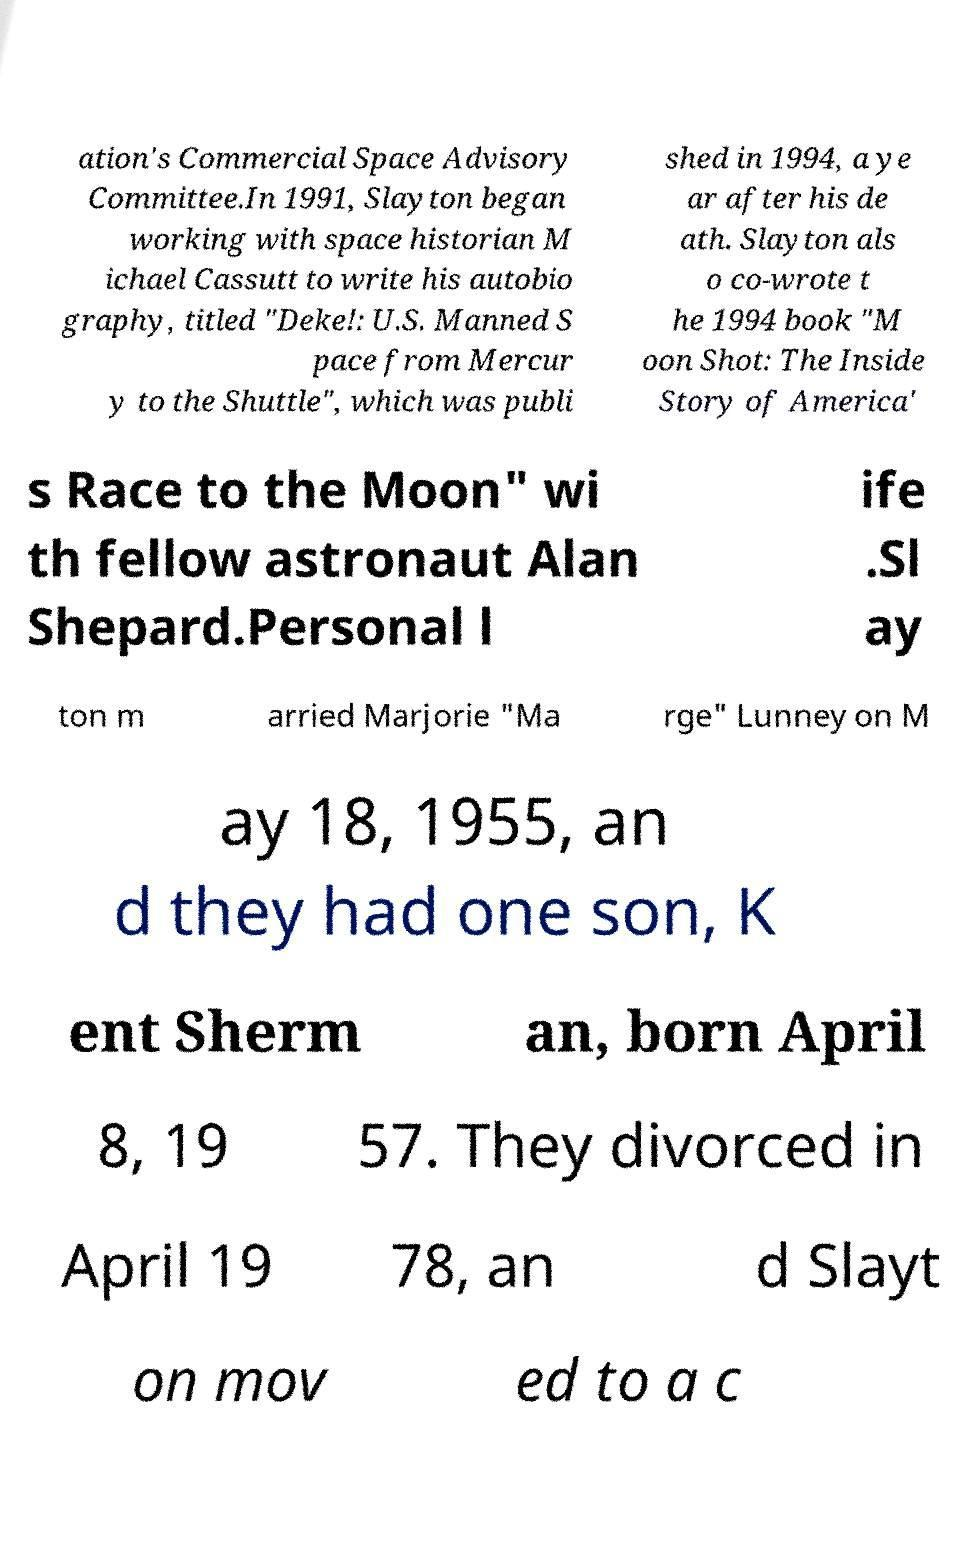There's text embedded in this image that I need extracted. Can you transcribe it verbatim? ation's Commercial Space Advisory Committee.In 1991, Slayton began working with space historian M ichael Cassutt to write his autobio graphy, titled "Deke!: U.S. Manned S pace from Mercur y to the Shuttle", which was publi shed in 1994, a ye ar after his de ath. Slayton als o co-wrote t he 1994 book "M oon Shot: The Inside Story of America' s Race to the Moon" wi th fellow astronaut Alan Shepard.Personal l ife .Sl ay ton m arried Marjorie "Ma rge" Lunney on M ay 18, 1955, an d they had one son, K ent Sherm an, born April 8, 19 57. They divorced in April 19 78, an d Slayt on mov ed to a c 